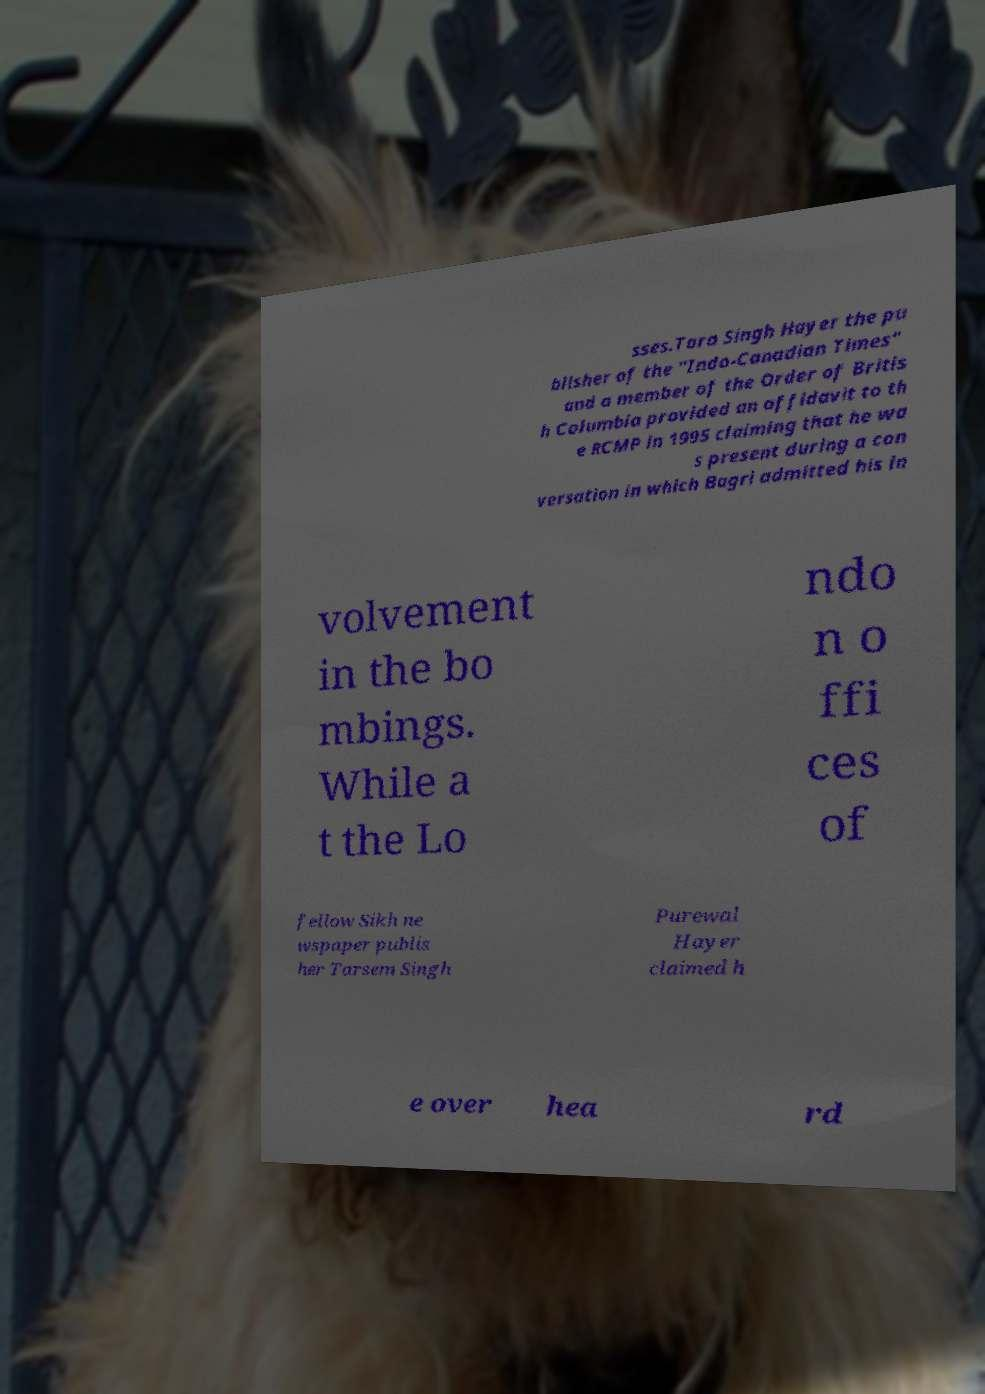Could you assist in decoding the text presented in this image and type it out clearly? sses.Tara Singh Hayer the pu blisher of the "Indo-Canadian Times" and a member of the Order of Britis h Columbia provided an affidavit to th e RCMP in 1995 claiming that he wa s present during a con versation in which Bagri admitted his in volvement in the bo mbings. While a t the Lo ndo n o ffi ces of fellow Sikh ne wspaper publis her Tarsem Singh Purewal Hayer claimed h e over hea rd 